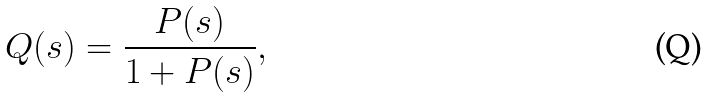Convert formula to latex. <formula><loc_0><loc_0><loc_500><loc_500>Q ( s ) = \frac { P ( s ) } { 1 + P ( s ) } ,</formula> 